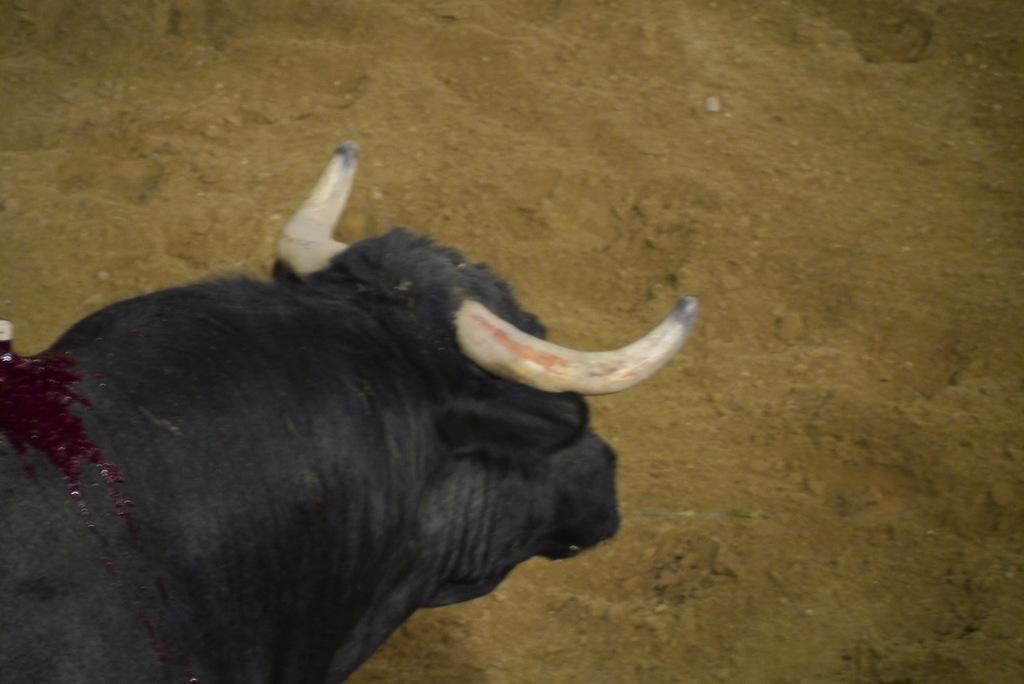What type of animal can be seen in the image? There is an animal in the image, but the specific type cannot be determined from the provided facts. What can be seen in the background of the image? There is sand visible in the background of the image. How many eggs are being played by the band in the image? There is no band or eggs present in the image. 